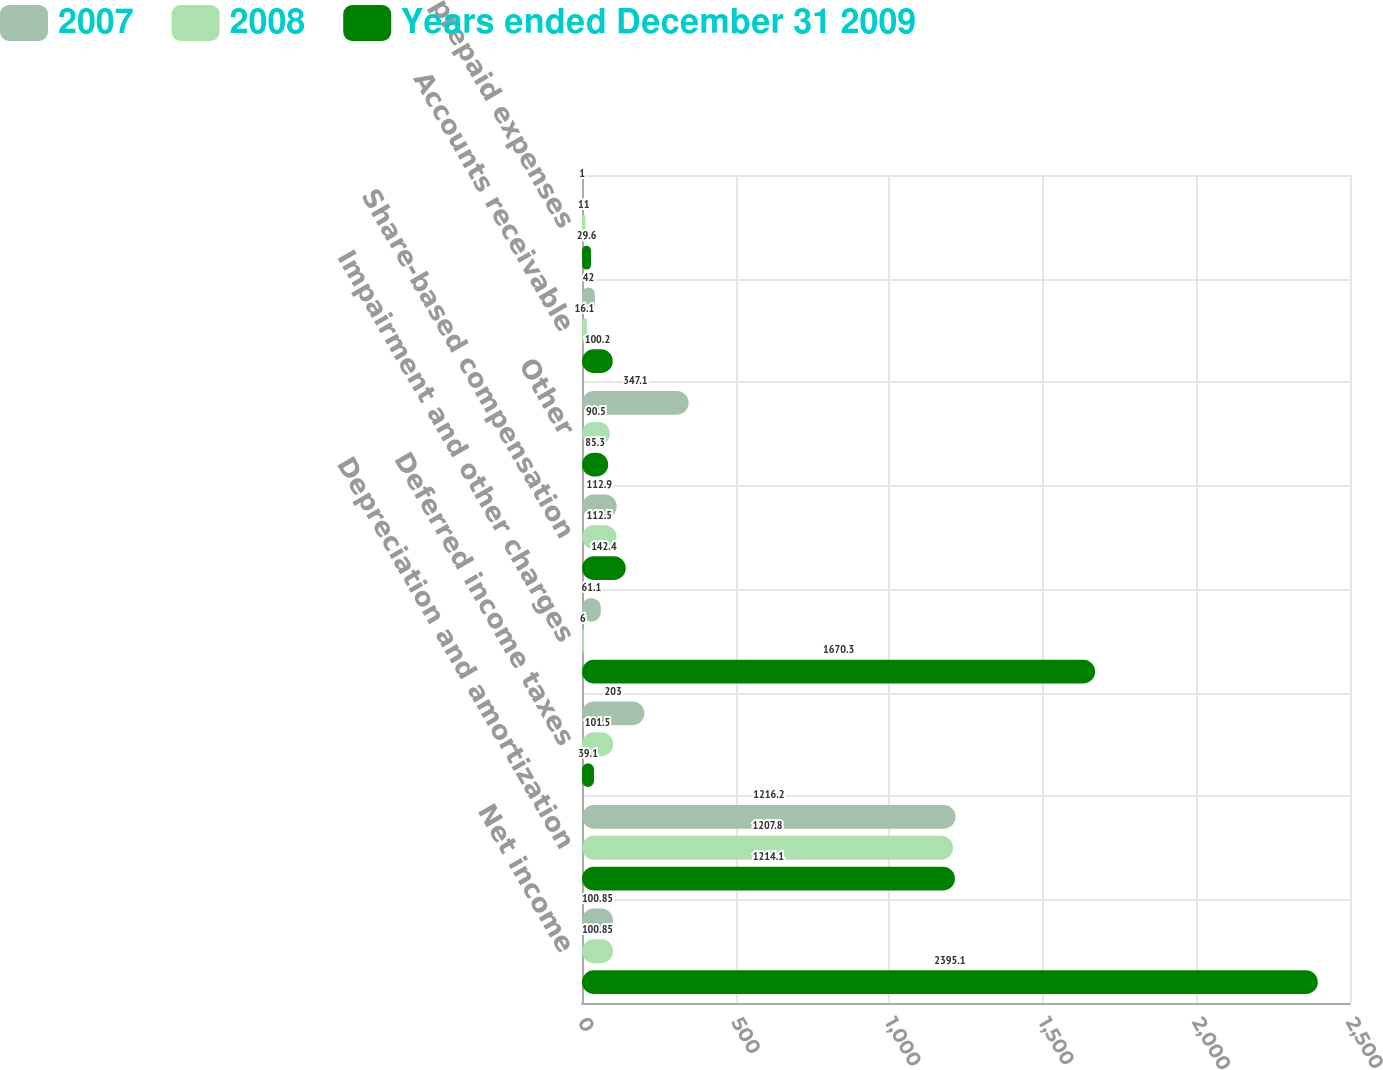Convert chart. <chart><loc_0><loc_0><loc_500><loc_500><stacked_bar_chart><ecel><fcel>Net income<fcel>Depreciation and amortization<fcel>Deferred income taxes<fcel>Impairment and other charges<fcel>Share-based compensation<fcel>Other<fcel>Accounts receivable<fcel>Inventories prepaid expenses<nl><fcel>2007<fcel>100.85<fcel>1216.2<fcel>203<fcel>61.1<fcel>112.9<fcel>347.1<fcel>42<fcel>1<nl><fcel>2008<fcel>100.85<fcel>1207.8<fcel>101.5<fcel>6<fcel>112.5<fcel>90.5<fcel>16.1<fcel>11<nl><fcel>Years ended December 31 2009<fcel>2395.1<fcel>1214.1<fcel>39.1<fcel>1670.3<fcel>142.4<fcel>85.3<fcel>100.2<fcel>29.6<nl></chart> 